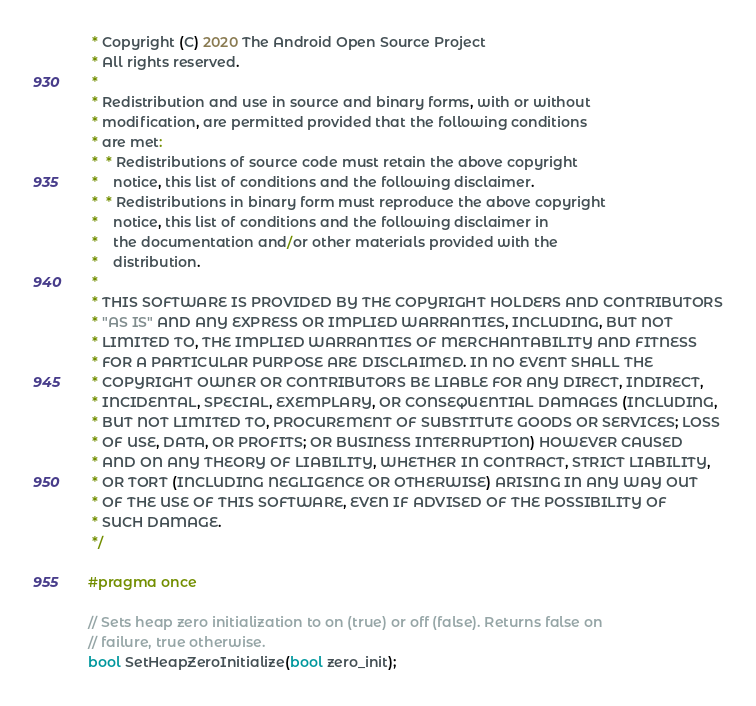Convert code to text. <code><loc_0><loc_0><loc_500><loc_500><_C_> * Copyright (C) 2020 The Android Open Source Project
 * All rights reserved.
 *
 * Redistribution and use in source and binary forms, with or without
 * modification, are permitted provided that the following conditions
 * are met:
 *  * Redistributions of source code must retain the above copyright
 *    notice, this list of conditions and the following disclaimer.
 *  * Redistributions in binary form must reproduce the above copyright
 *    notice, this list of conditions and the following disclaimer in
 *    the documentation and/or other materials provided with the
 *    distribution.
 *
 * THIS SOFTWARE IS PROVIDED BY THE COPYRIGHT HOLDERS AND CONTRIBUTORS
 * "AS IS" AND ANY EXPRESS OR IMPLIED WARRANTIES, INCLUDING, BUT NOT
 * LIMITED TO, THE IMPLIED WARRANTIES OF MERCHANTABILITY AND FITNESS
 * FOR A PARTICULAR PURPOSE ARE DISCLAIMED. IN NO EVENT SHALL THE
 * COPYRIGHT OWNER OR CONTRIBUTORS BE LIABLE FOR ANY DIRECT, INDIRECT,
 * INCIDENTAL, SPECIAL, EXEMPLARY, OR CONSEQUENTIAL DAMAGES (INCLUDING,
 * BUT NOT LIMITED TO, PROCUREMENT OF SUBSTITUTE GOODS OR SERVICES; LOSS
 * OF USE, DATA, OR PROFITS; OR BUSINESS INTERRUPTION) HOWEVER CAUSED
 * AND ON ANY THEORY OF LIABILITY, WHETHER IN CONTRACT, STRICT LIABILITY,
 * OR TORT (INCLUDING NEGLIGENCE OR OTHERWISE) ARISING IN ANY WAY OUT
 * OF THE USE OF THIS SOFTWARE, EVEN IF ADVISED OF THE POSSIBILITY OF
 * SUCH DAMAGE.
 */

#pragma once

// Sets heap zero initialization to on (true) or off (false). Returns false on
// failure, true otherwise.
bool SetHeapZeroInitialize(bool zero_init);
</code> 